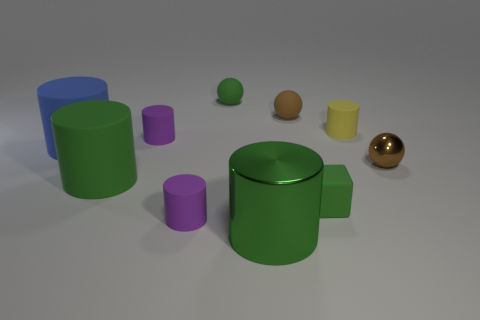What is the size of the cylinder that is on the right side of the shiny object on the left side of the small yellow cylinder?
Keep it short and to the point. Small. Does the brown thing behind the yellow rubber cylinder have the same shape as the brown object that is in front of the blue rubber cylinder?
Make the answer very short. Yes. There is a tiny cylinder that is both in front of the yellow cylinder and behind the blue rubber cylinder; what color is it?
Provide a short and direct response. Purple. Are there any rubber cylinders that have the same color as the tiny metallic ball?
Ensure brevity in your answer.  No. The tiny matte object in front of the green rubber cube is what color?
Provide a succinct answer. Purple. Is there a purple thing that is right of the tiny ball that is to the right of the matte block?
Your answer should be very brief. No. There is a large metal cylinder; is its color the same as the small ball to the left of the green metallic cylinder?
Make the answer very short. Yes. Is there a green sphere that has the same material as the small yellow object?
Your answer should be compact. Yes. What number of big red shiny spheres are there?
Provide a succinct answer. 0. What is the brown thing that is in front of the small purple matte cylinder behind the large blue rubber object made of?
Your answer should be compact. Metal. 